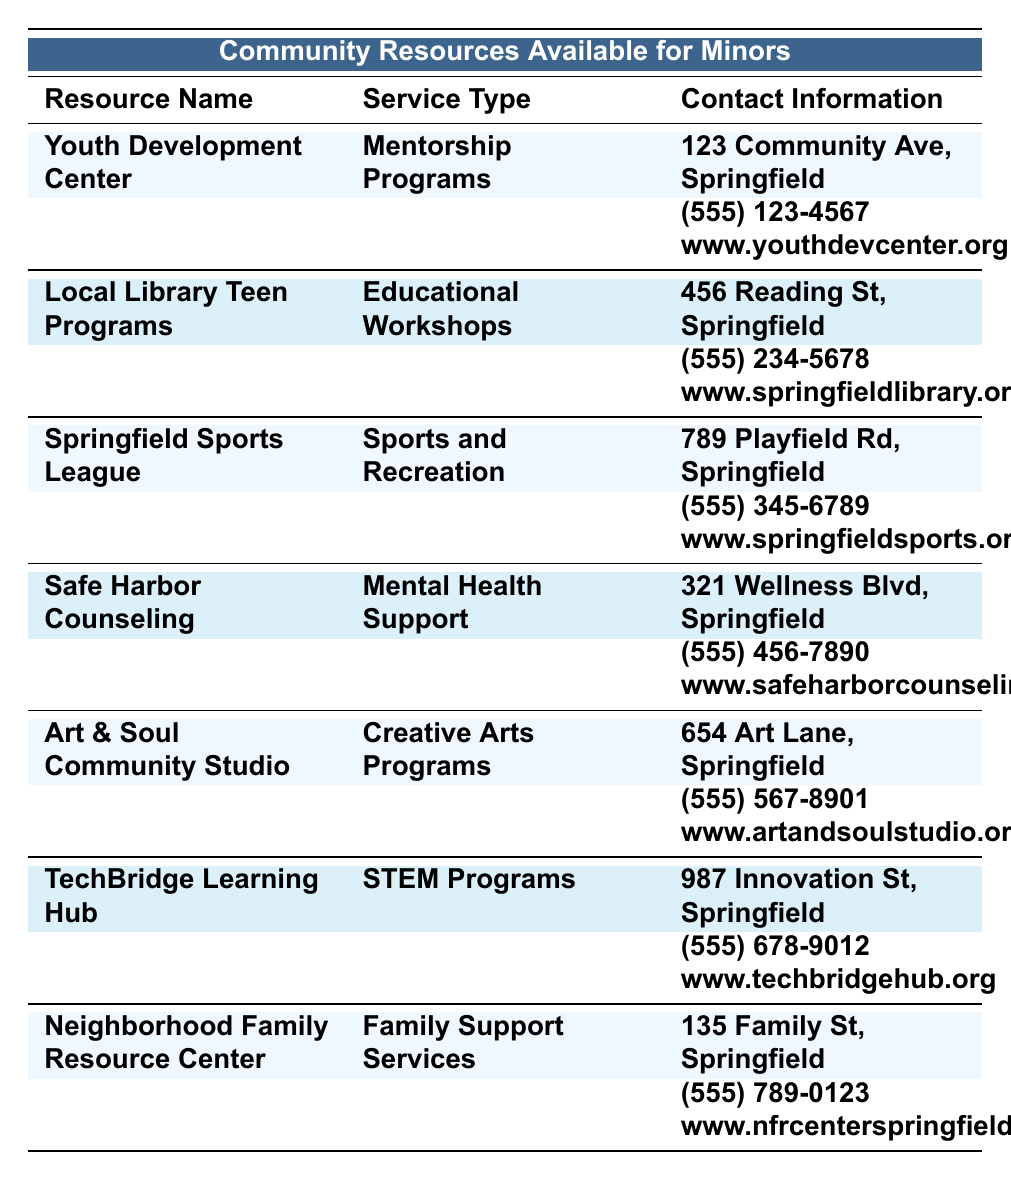What is the contact number for the Youth Development Center? The contact number for the Youth Development Center is listed in the table as (555) 123-4567.
Answer: (555) 123-4567 Which resource is focused on providing mental health support? The table indicates that Safe Harbor Counseling provides mental health support.
Answer: Safe Harbor Counseling What is the service type provided at the Local Library Teen Programs? The service type is listed as Educational Workshops for the Local Library Teen Programs.
Answer: Educational Workshops Which two resources offer creative programs? By checking the service types, Art & Soul Community Studio offers Creative Arts Programs and TechBridge Learning Hub offers STEM Programs, but TechBridge does not specifically offer creative programs. Only one fits, Art & Soul Community Studio does.
Answer: Art & Soul Community Studio Where is the Springfield Sports League located? It is located at 789 Playfield Rd, Springfield according to the table.
Answer: 789 Playfield Rd, Springfield Is there a resource that provides family support services? Yes, the Neighborhood Family Resource Center offers family support services, as noted in the table.
Answer: Yes What types of programs are provided for minors by the Youth Development Center? The Youth Development Center provides mentorship programs, as specified in the table.
Answer: Mentorship Programs How many services are classified under sports and recreation? There is only one service listed under Sports and Recreation, which is provided by Springfield Sports League.
Answer: 1 Which resource focuses on technology for minors? The resource that focuses on technology for minors is TechBridge Learning Hub, providing STEM programs.
Answer: TechBridge Learning Hub Among the resources, which one is located on Family St? The Neighborhood Family Resource Center is located at 135 Family St, as mentioned in the table.
Answer: Neighborhood Family Resource Center Which two resources are located at addresses with "Springfield" in them? All resources listed in the table are located in Springfield, so the answer includes all; however, any specific pairs can be chosen, like Safe Harbor Counseling and Springfield Sports League.
Answer: All resources 